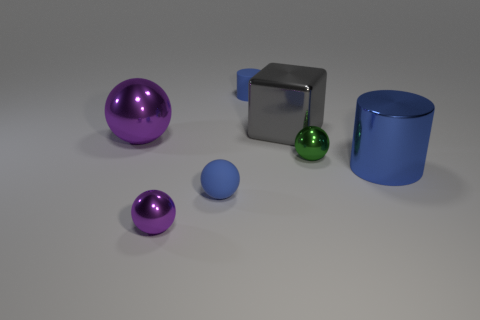Add 1 gray blocks. How many objects exist? 8 Subtract all cubes. How many objects are left? 6 Add 5 large metallic balls. How many large metallic balls exist? 6 Subtract 0 cyan cylinders. How many objects are left? 7 Subtract all large red rubber spheres. Subtract all gray objects. How many objects are left? 6 Add 3 gray shiny cubes. How many gray shiny cubes are left? 4 